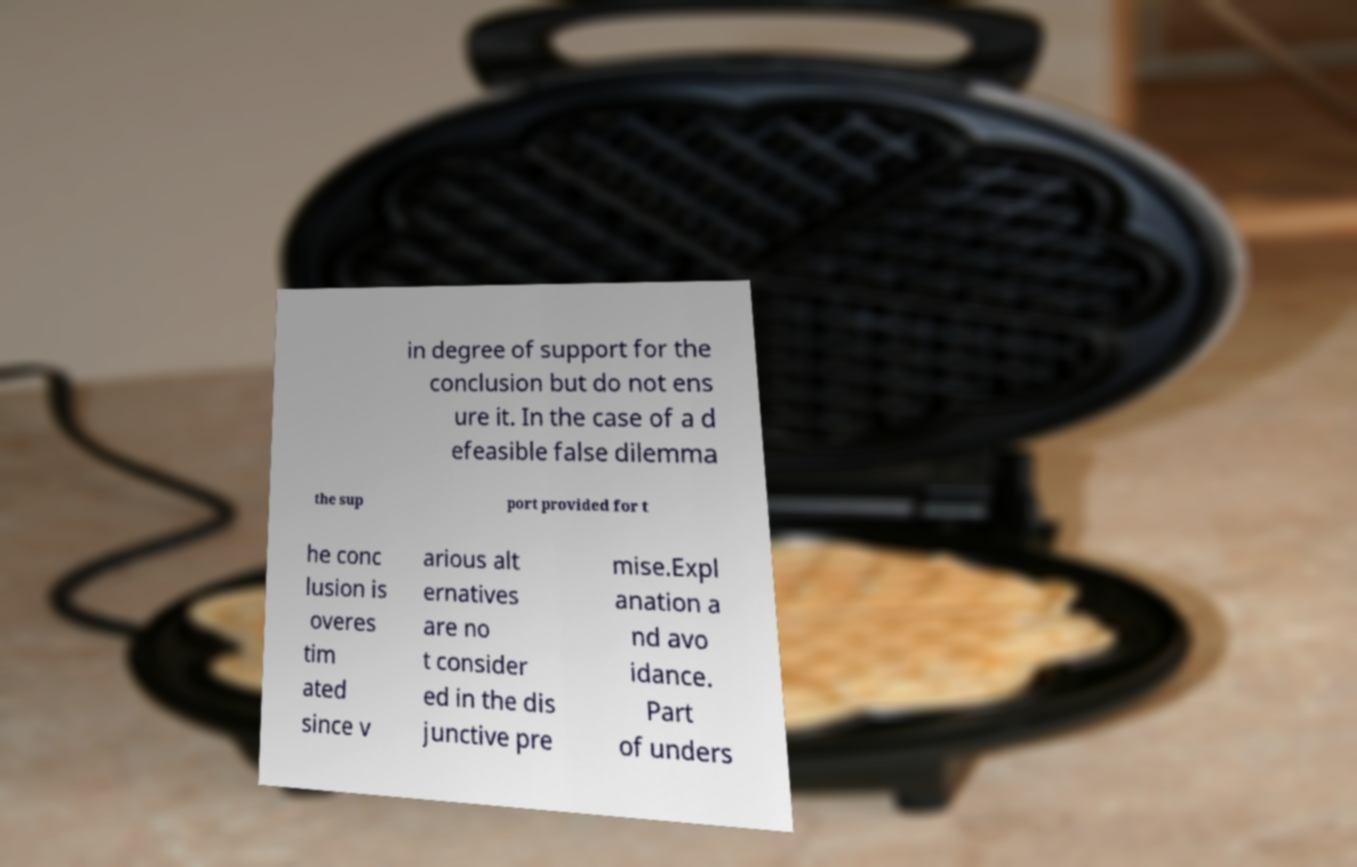I need the written content from this picture converted into text. Can you do that? in degree of support for the conclusion but do not ens ure it. In the case of a d efeasible false dilemma the sup port provided for t he conc lusion is overes tim ated since v arious alt ernatives are no t consider ed in the dis junctive pre mise.Expl anation a nd avo idance. Part of unders 